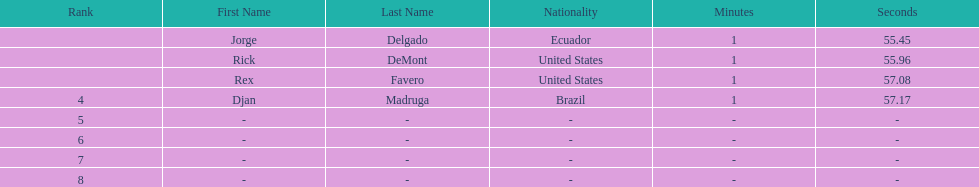How many ranked swimmers were from the united states? 2. 